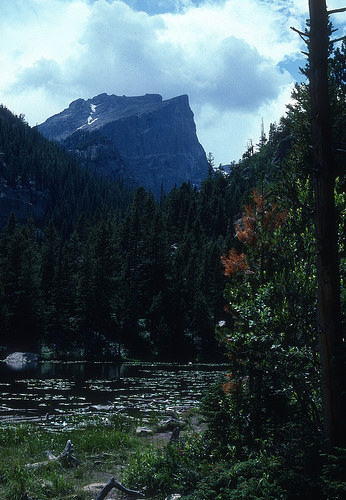<image>
Can you confirm if the mountain is on the tree? No. The mountain is not positioned on the tree. They may be near each other, but the mountain is not supported by or resting on top of the tree. 